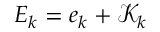<formula> <loc_0><loc_0><loc_500><loc_500>E _ { k } = e _ { k } + \mathcal { K } _ { k }</formula> 